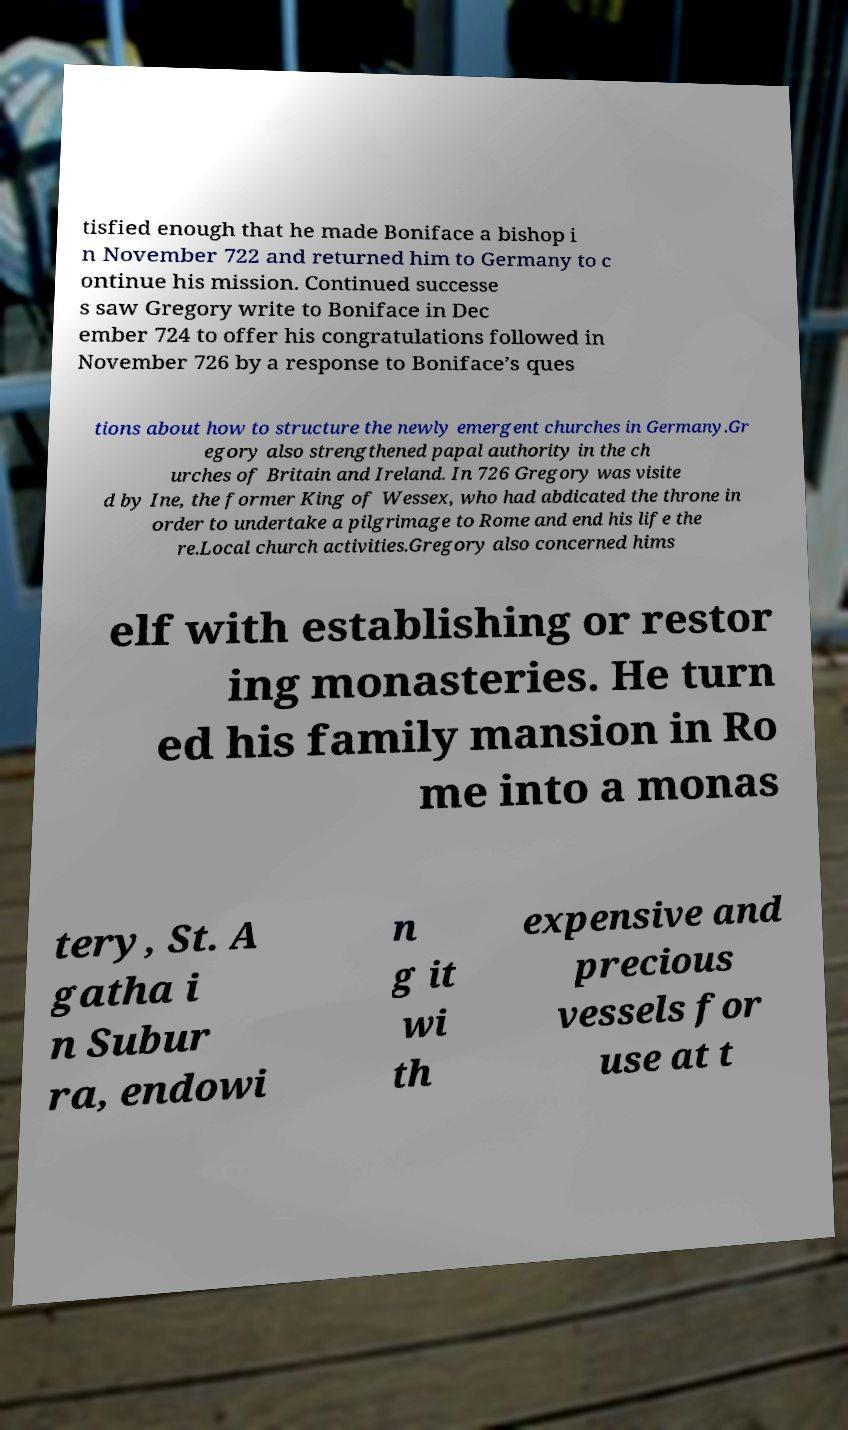There's text embedded in this image that I need extracted. Can you transcribe it verbatim? tisfied enough that he made Boniface a bishop i n November 722 and returned him to Germany to c ontinue his mission. Continued successe s saw Gregory write to Boniface in Dec ember 724 to offer his congratulations followed in November 726 by a response to Boniface’s ques tions about how to structure the newly emergent churches in Germany.Gr egory also strengthened papal authority in the ch urches of Britain and Ireland. In 726 Gregory was visite d by Ine, the former King of Wessex, who had abdicated the throne in order to undertake a pilgrimage to Rome and end his life the re.Local church activities.Gregory also concerned hims elf with establishing or restor ing monasteries. He turn ed his family mansion in Ro me into a monas tery, St. A gatha i n Subur ra, endowi n g it wi th expensive and precious vessels for use at t 